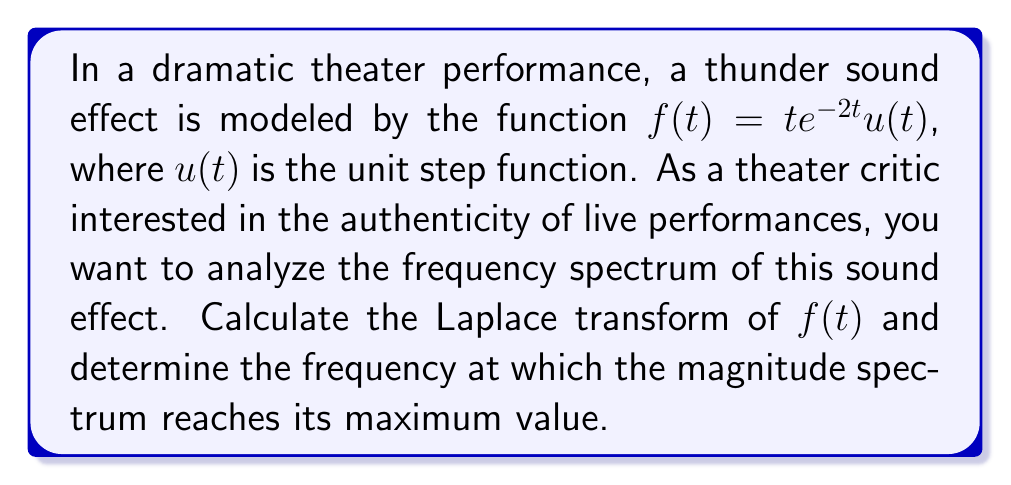Can you solve this math problem? Let's approach this step-by-step:

1) The Laplace transform of $f(t) = te^{-2t}u(t)$ is given by:

   $$F(s) = \int_0^\infty te^{-2t}e^{-st}dt$$

2) This integral can be solved using integration by parts. Let $u = t$ and $dv = e^{-(s+2)t}dt$. Then $du = dt$ and $v = -\frac{1}{s+2}e^{-(s+2)t}$.

3) Applying integration by parts:

   $$F(s) = \left[-\frac{t}{s+2}e^{-(s+2)t}\right]_0^\infty + \int_0^\infty \frac{1}{s+2}e^{-(s+2)t}dt$$

4) The first term evaluates to zero at both limits. For the second term:

   $$F(s) = \frac{1}{s+2}\int_0^\infty e^{-(s+2)t}dt = \frac{1}{s+2}\left[-\frac{1}{s+2}e^{-(s+2)t}\right]_0^\infty = \frac{1}{(s+2)^2}$$

5) To find the magnitude spectrum, we replace $s$ with $j\omega$:

   $$|F(j\omega)| = \left|\frac{1}{(j\omega+2)^2}\right| = \frac{1}{(\omega^2+4)}$$

6) To find the maximum of this function, we differentiate with respect to $\omega$ and set it to zero:

   $$\frac{d}{d\omega}\left(\frac{1}{\omega^2+4}\right) = -\frac{2\omega}{(\omega^2+4)^2} = 0$$

7) This equation is satisfied when $\omega = 0$, which corresponds to the maximum of the magnitude spectrum.
Answer: The Laplace transform of $f(t) = te^{-2t}u(t)$ is $F(s) = \frac{1}{(s+2)^2}$. The magnitude spectrum reaches its maximum value at a frequency of 0 Hz. 